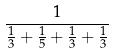<formula> <loc_0><loc_0><loc_500><loc_500>\frac { 1 } { \frac { 1 } { 3 } + \frac { 1 } { 5 } + \frac { 1 } { 3 } + \frac { 1 } { 3 } }</formula> 